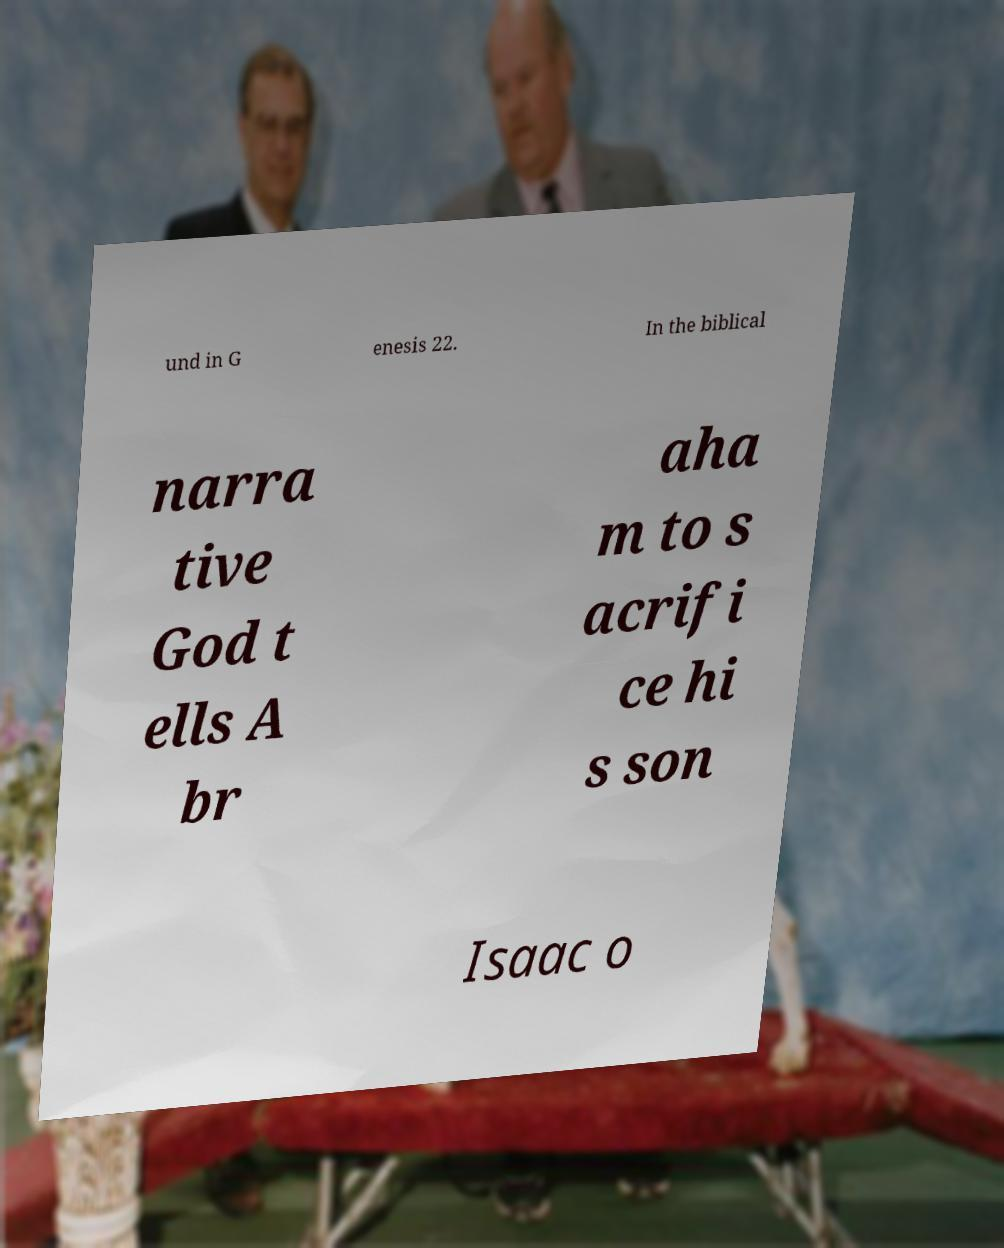Can you read and provide the text displayed in the image?This photo seems to have some interesting text. Can you extract and type it out for me? und in G enesis 22. In the biblical narra tive God t ells A br aha m to s acrifi ce hi s son Isaac o 